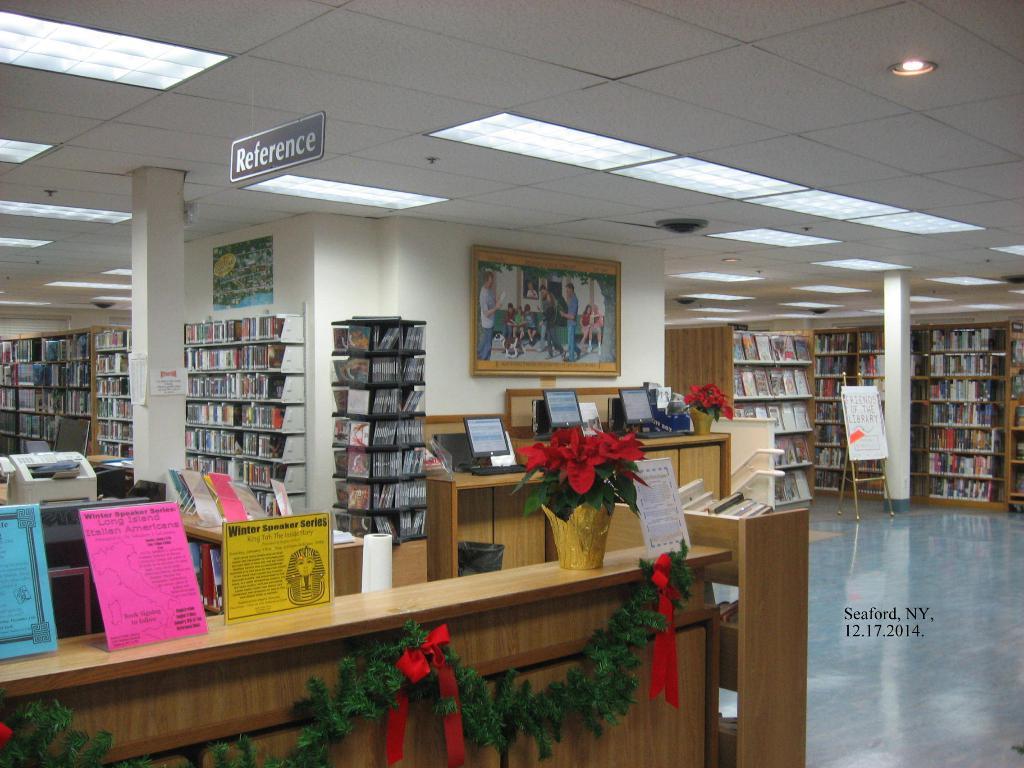Which section of the library is this?
Offer a terse response. Reference. 